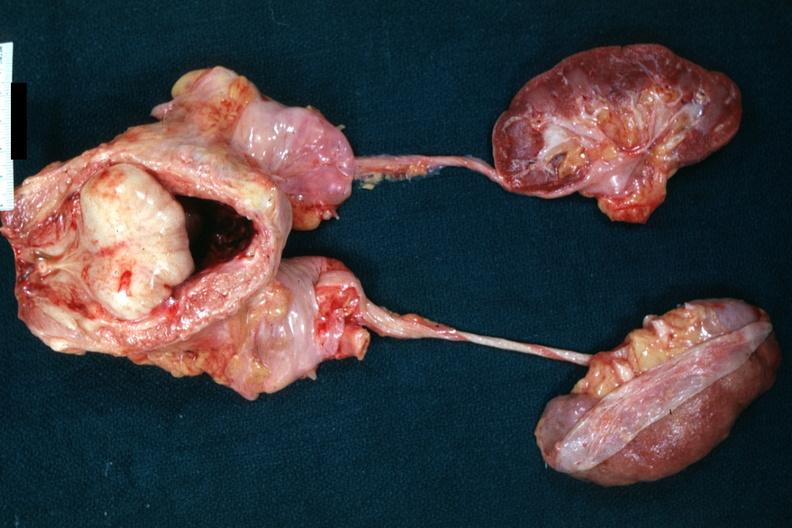what is present?
Answer the question using a single word or phrase. Hyperplasia 